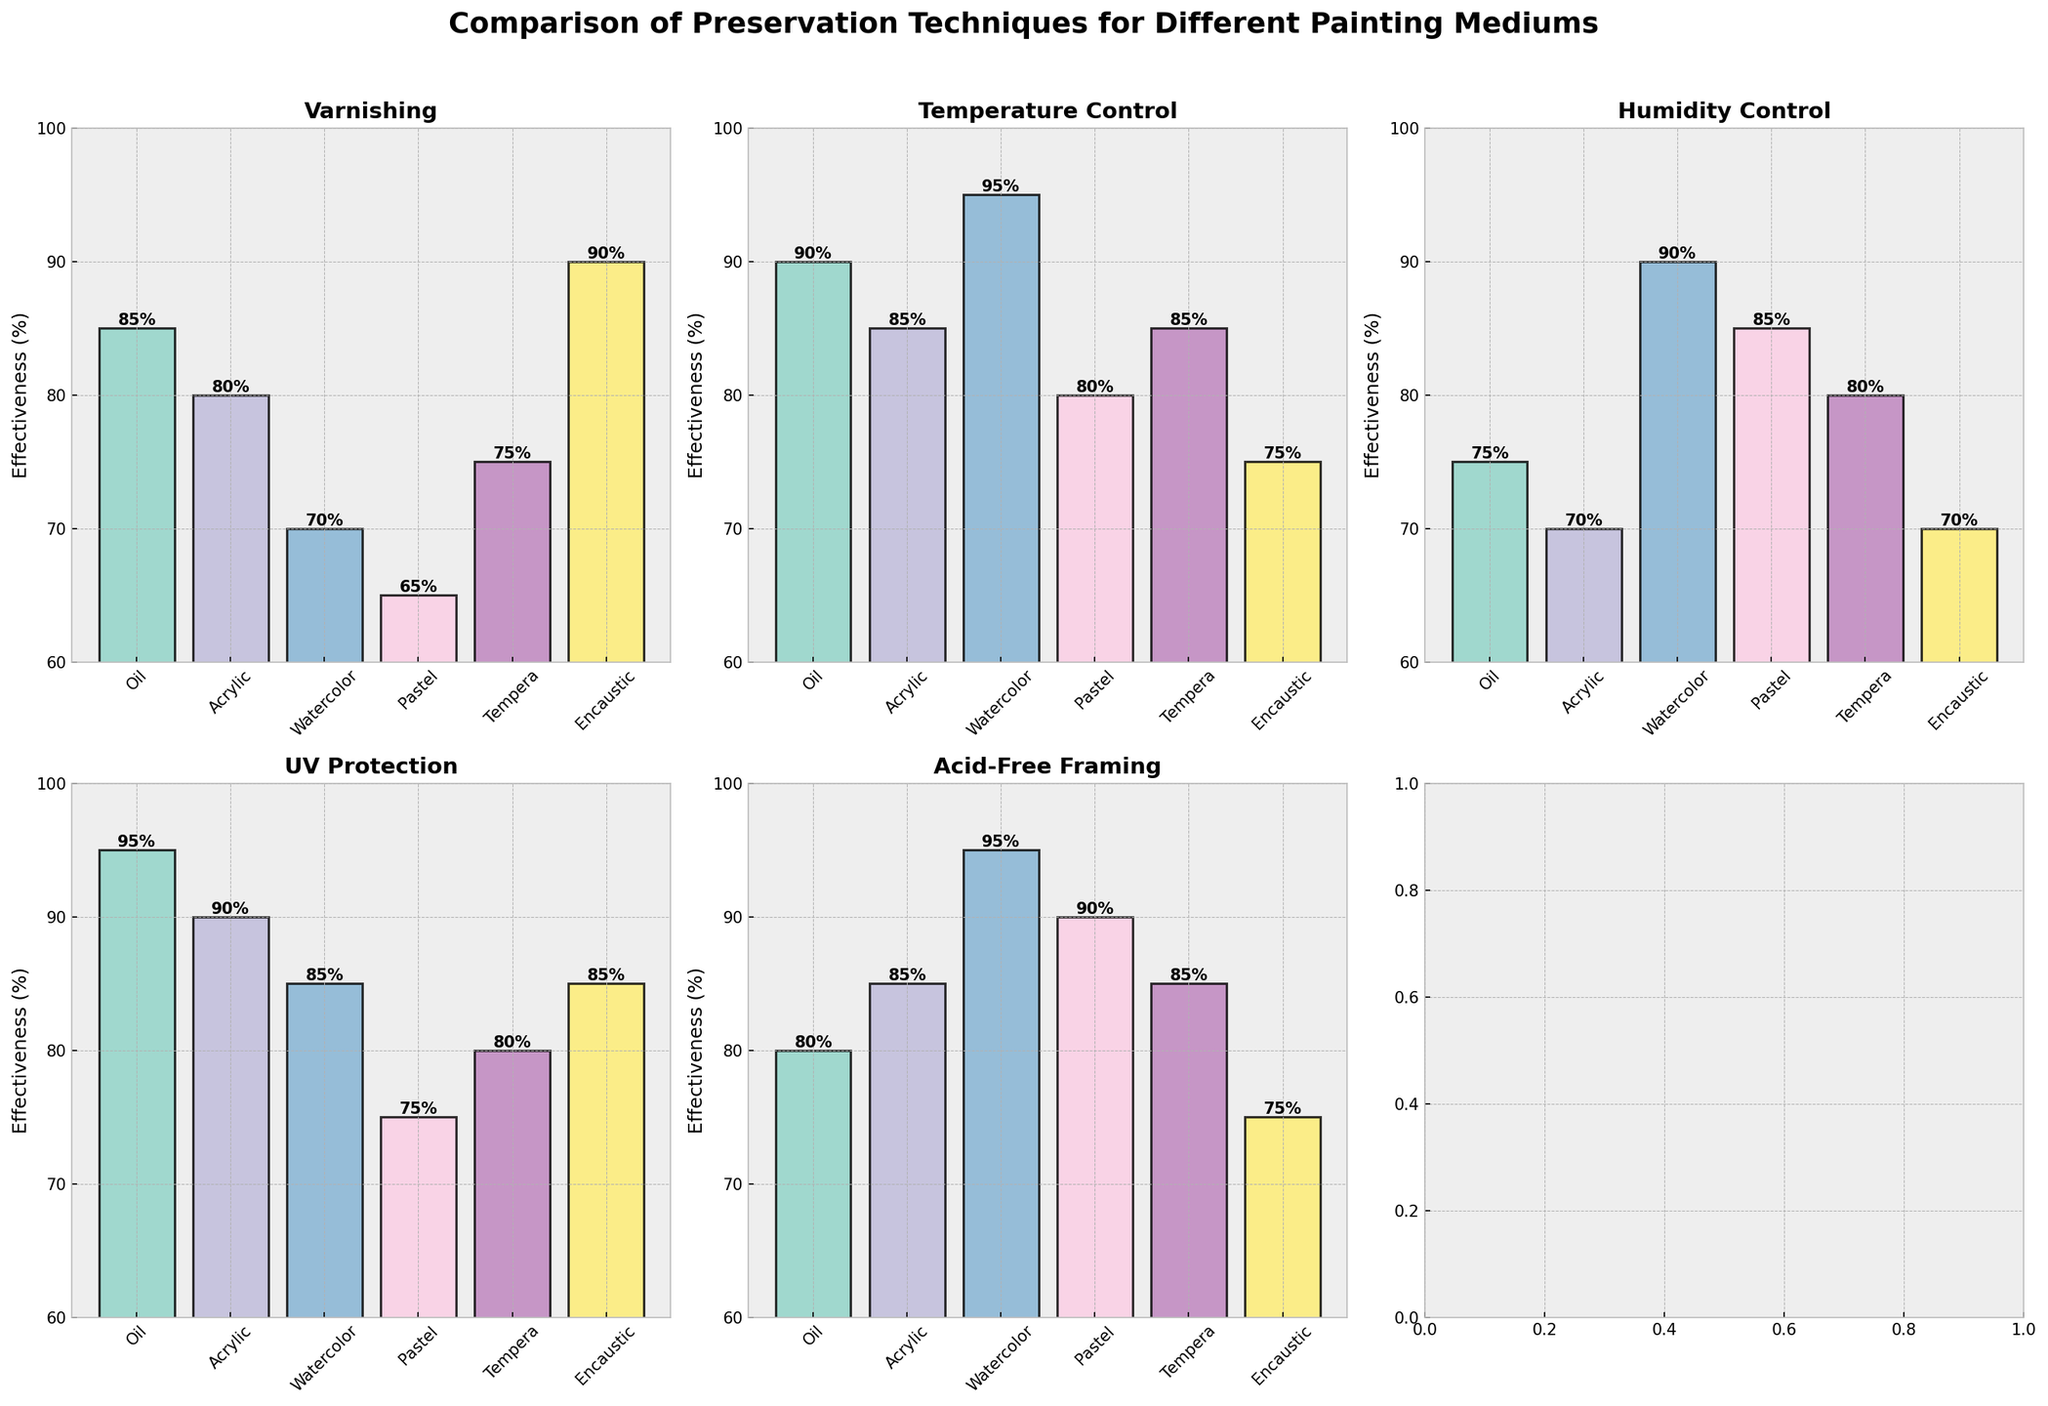What's the title of the figure? The title is typically at the top of the figure, often centered and in bold text. The title here is directly taken from the code section where it mentions `fig.suptitle`.
Answer: Comparison of Preservation Techniques for Different Painting Mediums Which preservation technique has the highest effectiveness for Oil painting? Look at the subplot related to Oil painting and identify the tallest bar. In this case, for Oil painting, the tallest bar is under UV Protection.
Answer: UV Protection What is the average effectiveness of Varnishing across all mediums? From the Varnishing subplot, note the effectiveness values for each painting medium and calculate the average: (85 + 80 + 70 + 65 + 75 + 90) / 6 = 465 / 6 = 77.5
Answer: 77.5 Which technique has the lowest effectiveness for Pastel painting? In the Pastel subplot, identify the shortest bar which indicates the lowest value. The shortest bar for Pastel is under Varnishing.
Answer: Varnishing Compare the effectiveness of Temperature Control between Encaustic and Watercolor paintings. Which one is higher? From the Temperature Control subplot, compare the heights of the bars labeled Encaustic and Watercolor. Watercolor has a higher bar at 95 compared to Encaustic at 75.
Answer: Watercolor For which medium is Humidity Control more effective than Varnishing and UV Protection? Check the Humidity Control subplot and compare it to the Varnishing and UV Protection subplots for each medium. Watercolor has a higher bar for Humidity Control (90) than Varnishing (70) and UV Protection (85).
Answer: Watercolor What is the median effectiveness value of Acid-Free Framing across all mediums? Arrange the Acid-Free Framing effectiveness values in ascending order: 75, 80, 85, 85, 90, 95. The median is the average of the 3rd and 4th values: (85 + 85) / 2 = 85.
Answer: 85 Identify the preservation technique with consistent effectiveness values above 80% across all painting mediums. Check each subplot's bars to see if they are all above 80%. Only Temperature Control has values consistently above 80% for all mediums.
Answer: Temperature Control What is the effectiveness difference between UV Protection and Varnishing for Acrylic paintings? From the subplots, note the effectiveness values for UV Protection and Varnishing for Acrylic: 90 - 80 = 10.
Answer: 10 Which painting medium has the lowest average effectiveness across all preservation techniques? Calculate the average effectiveness for each medium across all techniques and identify the smallest: 
Oil: (85+90+75+95+80)/5 = 85
Acrylic: (80+85+70+90+85)/5 = 82
Watercolor: (70+95+90+85+95)/5 = 87
Pastel: (65+80+85+75+90)/5 = 79
Tempera: (75+85+80+80+85)/5 = 81
Encaustic: (90+75+70+85+75)/5 = 79
Pastel and Encaustic both have an average of 79, thus tied for the lowest.
Answer: Pastel and Encaustic 